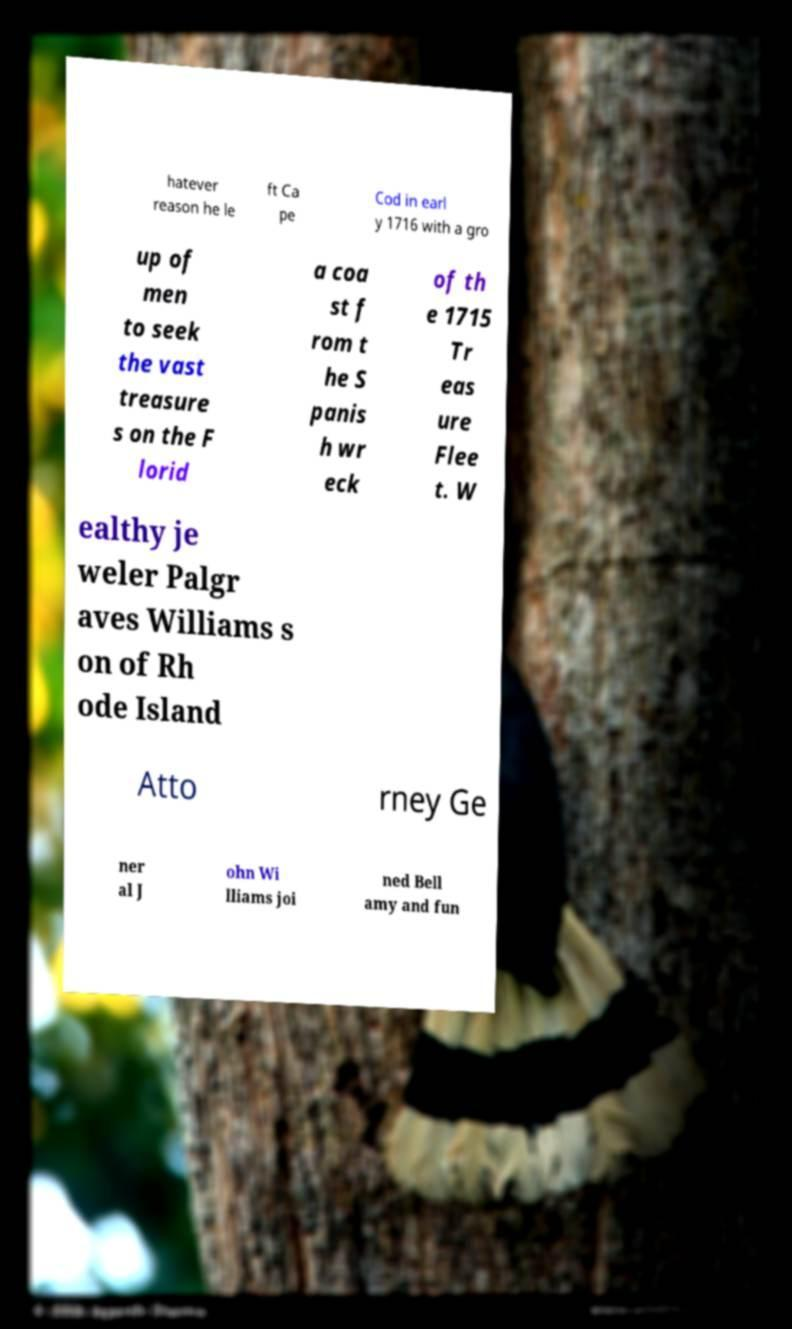Could you assist in decoding the text presented in this image and type it out clearly? hatever reason he le ft Ca pe Cod in earl y 1716 with a gro up of men to seek the vast treasure s on the F lorid a coa st f rom t he S panis h wr eck of th e 1715 Tr eas ure Flee t. W ealthy je weler Palgr aves Williams s on of Rh ode Island Atto rney Ge ner al J ohn Wi lliams joi ned Bell amy and fun 